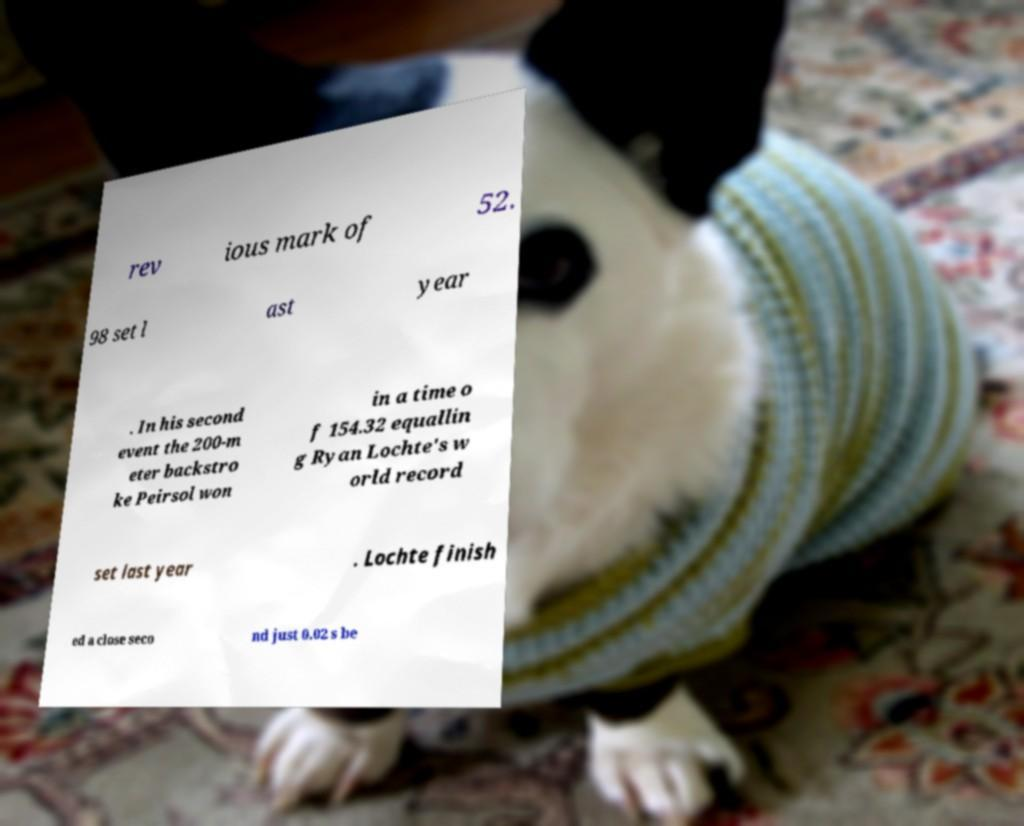Please read and relay the text visible in this image. What does it say? rev ious mark of 52. 98 set l ast year . In his second event the 200-m eter backstro ke Peirsol won in a time o f 154.32 equallin g Ryan Lochte's w orld record set last year . Lochte finish ed a close seco nd just 0.02 s be 